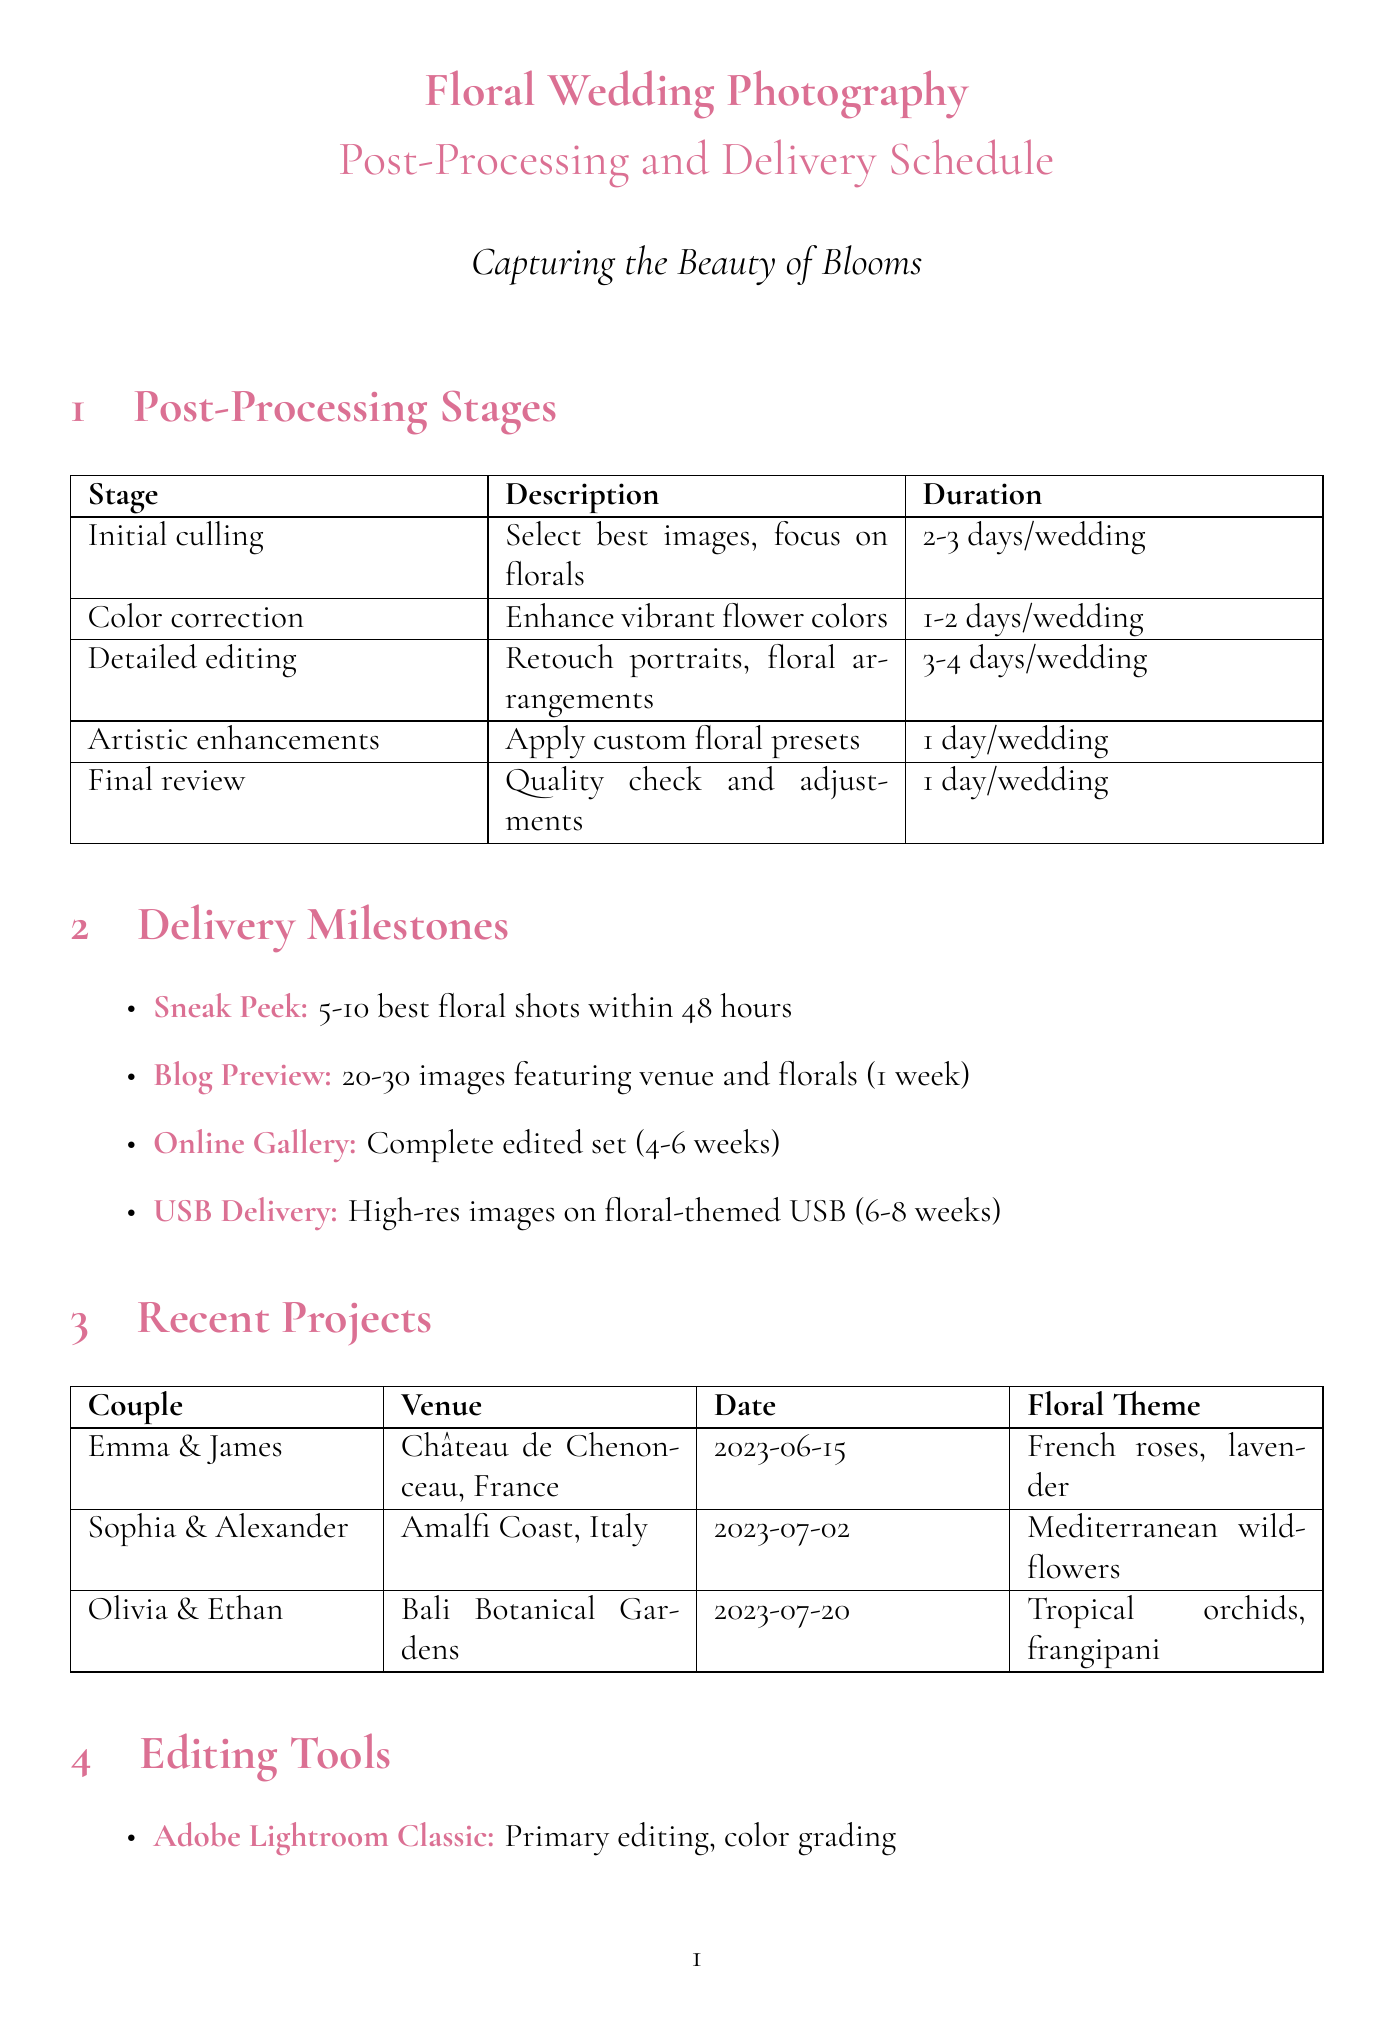What is the duration for initial culling? The document states that initial culling takes 2-3 days per wedding.
Answer: 2-3 days per wedding What is the floral theme for Olivia and Ethan's wedding? The floral theme for Olivia and Ethan is specified in the recent projects section as Tropical orchids and frangipani.
Answer: Tropical orchids and frangipani When is the USB delivery deadline? According to the delivery milestones, the USB delivery is due 6-8 weeks after the wedding.
Answer: 6-8 weeks after the wedding How many wedding projects are listed in the document? The document lists three recent wedding projects.
Answer: Three What editing software is used for detailed retouching? The document indicates that Adobe Photoshop is used for detailed retouching.
Answer: Adobe Photoshop What is the purpose of the post-wedding follow-up? The document states the purpose is to send a thank you note and timeline reminder.
Answer: Thank you note and timeline reminder In which venue did Sophia and Alexander get married? The venue for Sophia and Alexander's wedding is listed as Amalfi Coast, Italy.
Answer: Amalfi Coast, Italy What is the first milestone delivery after the wedding? The first milestone is the Sneak peek, which includes 5-10 edited images.
Answer: Sneak peek What is the total duration of detailed editing? The document specifies that detailed editing takes 3-4 days per wedding.
Answer: 3-4 days per wedding 